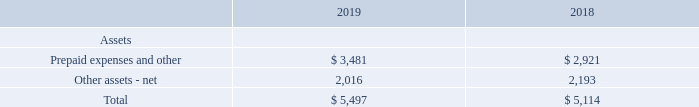Deferred contract costs are classified as current or non-current within prepaid expenses and other, and other assets – net, respectively. The balances of deferred contract costs as of December 31, 2019 and 2018, included in the balance sheet were as follows:
For the years ended December 31, 2019 and 2018, the Partnership recognized expense of $3,757 and $2,740, respectively associated with the amortization of deferred contract costs, primarily within selling, general and administrative expenses in the statements of income.
Deferred contract costs are assessed for impairment on an annual basis. An impairment charge is recognized to the extent the carrying amount of a deferred cost exceeds the remaining amount of consideration expected to be received in exchange for the goods and services related to the cost, less the expected costs related directly to providing those goods and services that have not yet been recognized as expenses. There have been no impairment charges recognized for the year ended December 31, 2019 and 2018.
What was the expense recognized by the Partnership in 2019?  $3,757. What is the Prepaid expenses and other for 2019? $ 3,481. How often are Deferred contract costs are assessed for impairment? On an annual basis. What was the increase / (decrease) in the prepaid expenses and other assets from 2018 to 2019? 3,481 - 2,921
Answer: 560. What was the average other assets-net for 2018 and 2019? (2,016 + 2,193) / 2
Answer: 2104.5. What was the percentage increase / (decrease) in the total assets from 2018 to 2019?
Answer scale should be: percent. 5,497 / 5,114 - 1
Answer: 7.49. 